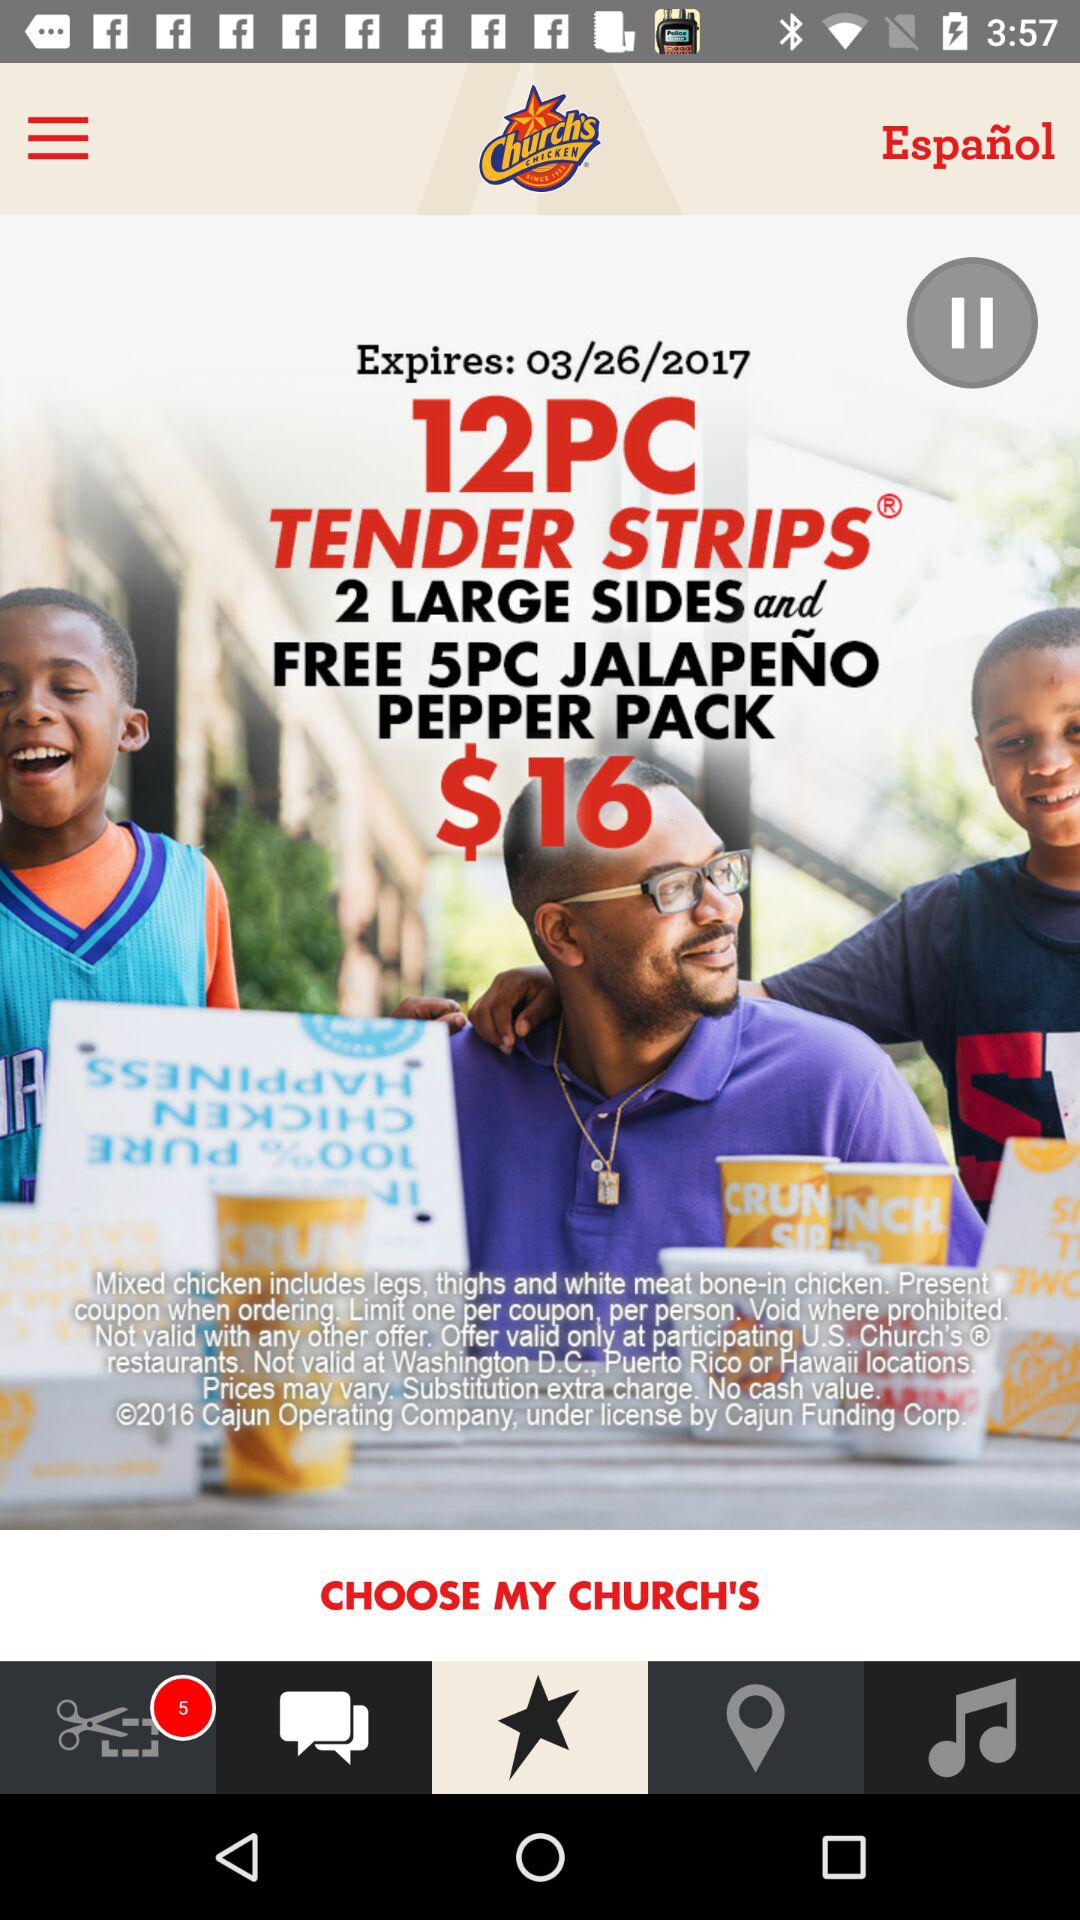What is the number of pieces of tender strips? The number of pieces of tender strips is 12. 